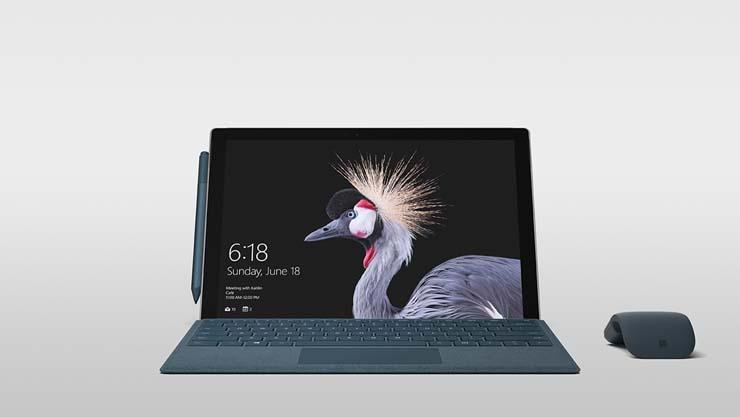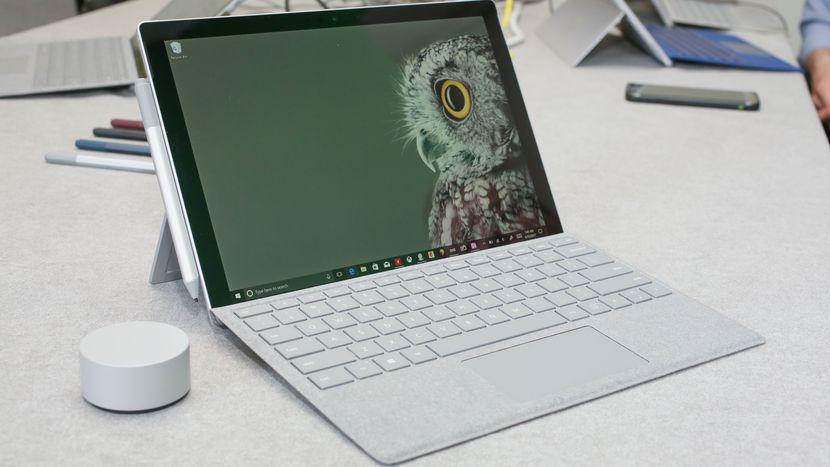The first image is the image on the left, the second image is the image on the right. For the images shown, is this caption "there is a stylus on the table next to a laptop" true? Answer yes or no. No. The first image is the image on the left, the second image is the image on the right. Assess this claim about the two images: "There are no more than 2 stylus's sitting next to laptops.". Correct or not? Answer yes or no. No. 